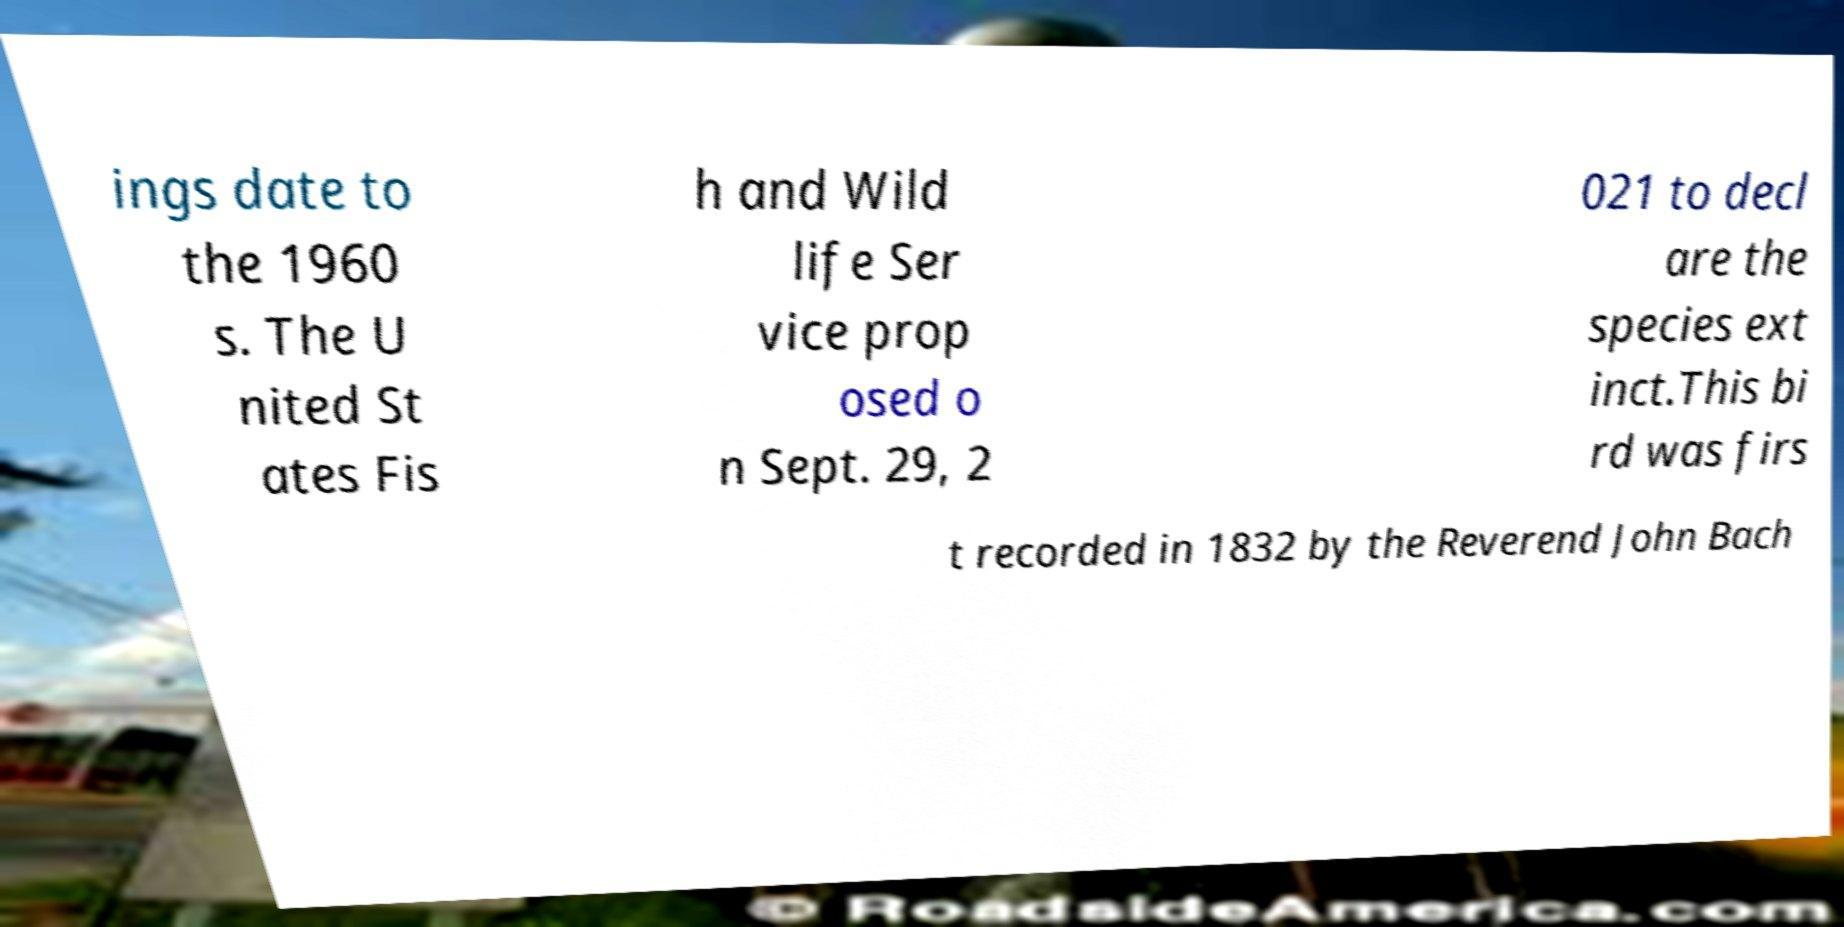Can you accurately transcribe the text from the provided image for me? ings date to the 1960 s. The U nited St ates Fis h and Wild life Ser vice prop osed o n Sept. 29, 2 021 to decl are the species ext inct.This bi rd was firs t recorded in 1832 by the Reverend John Bach 